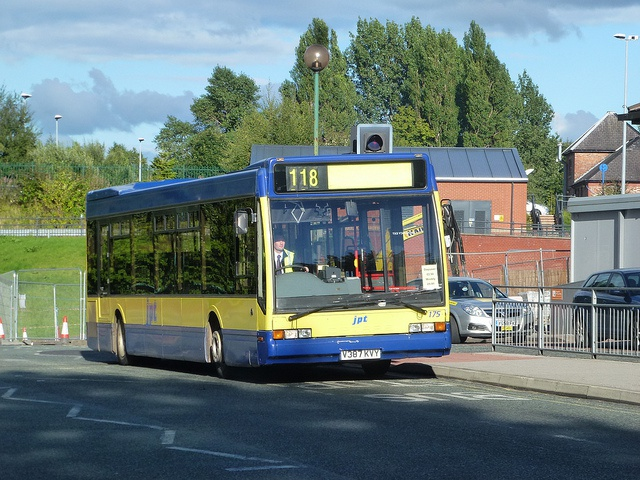Describe the objects in this image and their specific colors. I can see bus in lightblue, black, gray, blue, and navy tones, car in lightblue, darkgray, gray, and lightgray tones, car in lightblue, black, blue, navy, and gray tones, people in lightblue, gray, ivory, and black tones, and tie in lightblue, gray, darkgray, and lightgray tones in this image. 